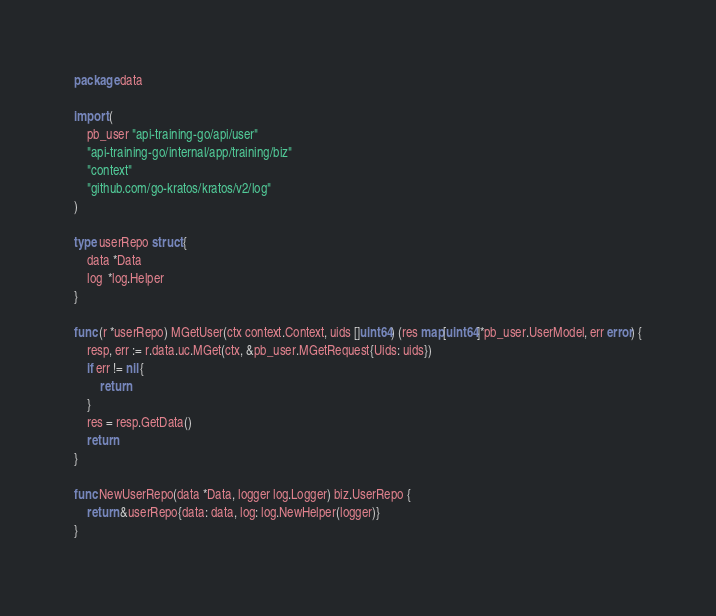<code> <loc_0><loc_0><loc_500><loc_500><_Go_>package data

import (
	pb_user "api-training-go/api/user"
	"api-training-go/internal/app/training/biz"
	"context"
	"github.com/go-kratos/kratos/v2/log"
)

type userRepo struct {
	data *Data
	log  *log.Helper
}

func (r *userRepo) MGetUser(ctx context.Context, uids []uint64) (res map[uint64]*pb_user.UserModel, err error) {
	resp, err := r.data.uc.MGet(ctx, &pb_user.MGetRequest{Uids: uids})
	if err != nil {
		return
	}
	res = resp.GetData()
	return
}

func NewUserRepo(data *Data, logger log.Logger) biz.UserRepo {
	return &userRepo{data: data, log: log.NewHelper(logger)}
}
</code> 